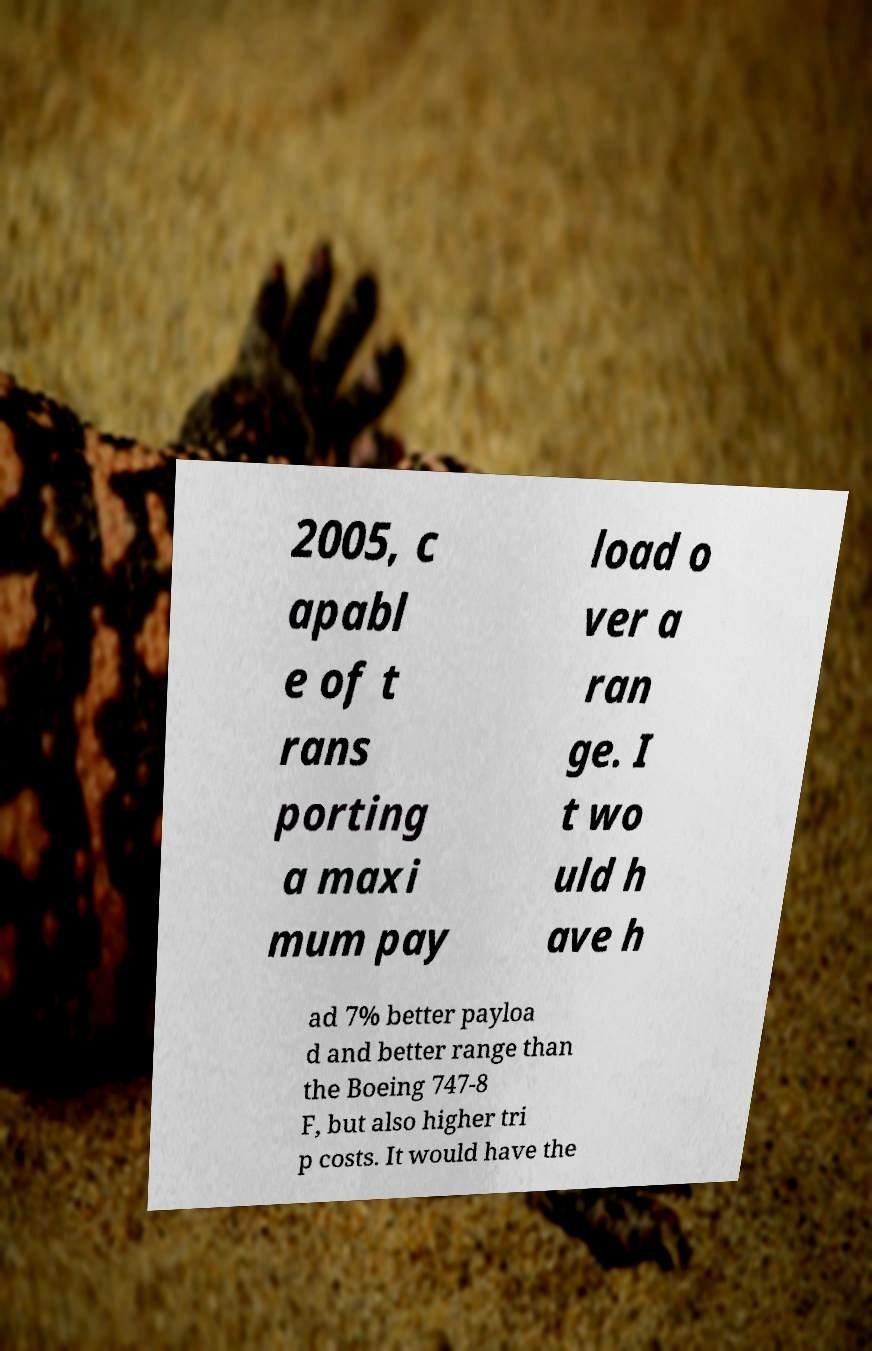Please identify and transcribe the text found in this image. 2005, c apabl e of t rans porting a maxi mum pay load o ver a ran ge. I t wo uld h ave h ad 7% better payloa d and better range than the Boeing 747-8 F, but also higher tri p costs. It would have the 